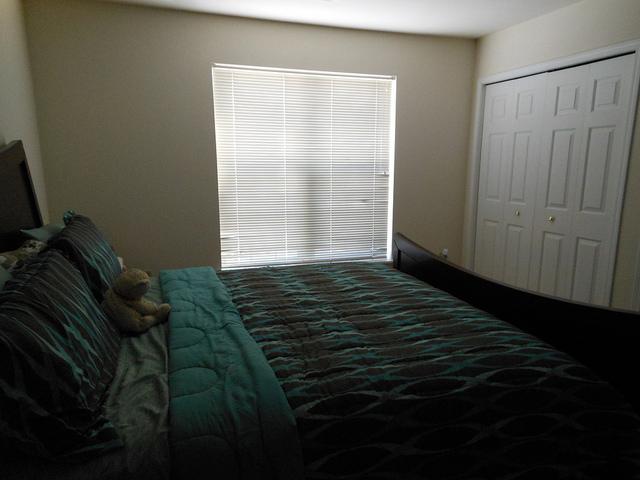What shape is on the blanket?
Be succinct. Diamonds. What color are the closet doors?
Keep it brief. White. What is the theme of the bedspread?
Short answer required. Green. What is likely beyond the door?
Quick response, please. Clothes. What is lying on the bed near the pillow?
Be succinct. Teddy bear. Are the blinds opened or closed?
Quick response, please. Closed. Where is the teddy bear?
Short answer required. On bed. Is there only a bed in this room?
Keep it brief. Yes. 